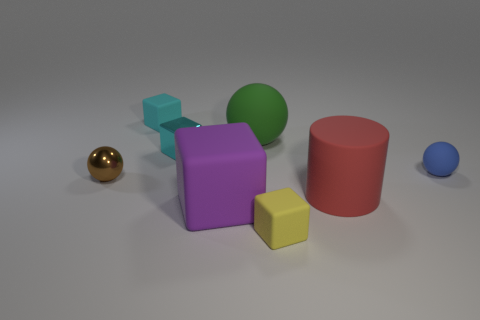Subtract all green spheres. How many cyan blocks are left? 2 Subtract all cyan rubber cubes. How many cubes are left? 3 Subtract all yellow cubes. How many cubes are left? 3 Add 1 small green rubber cylinders. How many objects exist? 9 Subtract 2 cubes. How many cubes are left? 2 Subtract all balls. How many objects are left? 5 Subtract all brown cubes. Subtract all gray cylinders. How many cubes are left? 4 Add 7 yellow balls. How many yellow balls exist? 7 Subtract 0 yellow balls. How many objects are left? 8 Subtract all metallic balls. Subtract all big gray matte blocks. How many objects are left? 7 